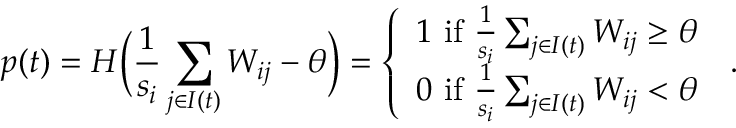<formula> <loc_0><loc_0><loc_500><loc_500>p ( t ) = H \left ( \frac { 1 } { s _ { i } } \sum _ { j \in I ( t ) } W _ { i j } - \theta \right ) = \left \{ \begin{array} { l l } { 1 i f \frac { 1 } { s _ { i } } \sum _ { j \in I ( t ) } W _ { i j } \geq \theta } \\ { 0 i f \frac { 1 } { s _ { i } } \sum _ { j \in I ( t ) } W _ { i j } < \theta } \end{array} \, .</formula> 